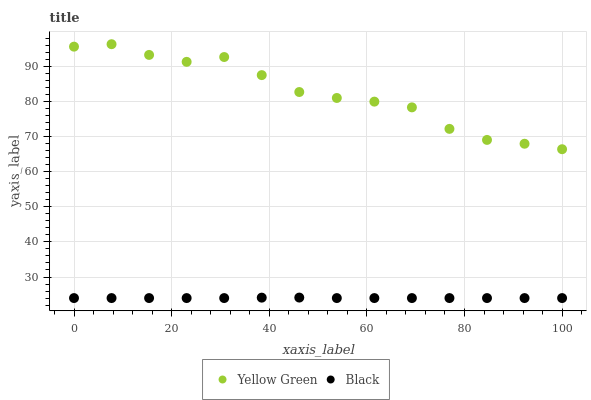Does Black have the minimum area under the curve?
Answer yes or no. Yes. Does Yellow Green have the maximum area under the curve?
Answer yes or no. Yes. Does Yellow Green have the minimum area under the curve?
Answer yes or no. No. Is Black the smoothest?
Answer yes or no. Yes. Is Yellow Green the roughest?
Answer yes or no. Yes. Is Yellow Green the smoothest?
Answer yes or no. No. Does Black have the lowest value?
Answer yes or no. Yes. Does Yellow Green have the lowest value?
Answer yes or no. No. Does Yellow Green have the highest value?
Answer yes or no. Yes. Is Black less than Yellow Green?
Answer yes or no. Yes. Is Yellow Green greater than Black?
Answer yes or no. Yes. Does Black intersect Yellow Green?
Answer yes or no. No. 